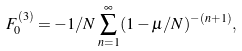<formula> <loc_0><loc_0><loc_500><loc_500>F _ { 0 } ^ { ( 3 ) } = - { 1 / N } \sum _ { n = 1 } ^ { \infty } ( 1 - \mu / N ) ^ { - ( n + 1 ) } ,</formula> 